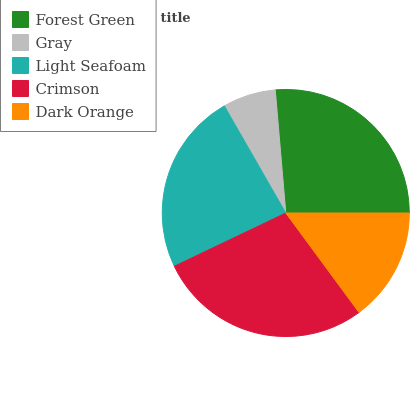Is Gray the minimum?
Answer yes or no. Yes. Is Crimson the maximum?
Answer yes or no. Yes. Is Light Seafoam the minimum?
Answer yes or no. No. Is Light Seafoam the maximum?
Answer yes or no. No. Is Light Seafoam greater than Gray?
Answer yes or no. Yes. Is Gray less than Light Seafoam?
Answer yes or no. Yes. Is Gray greater than Light Seafoam?
Answer yes or no. No. Is Light Seafoam less than Gray?
Answer yes or no. No. Is Light Seafoam the high median?
Answer yes or no. Yes. Is Light Seafoam the low median?
Answer yes or no. Yes. Is Dark Orange the high median?
Answer yes or no. No. Is Forest Green the low median?
Answer yes or no. No. 